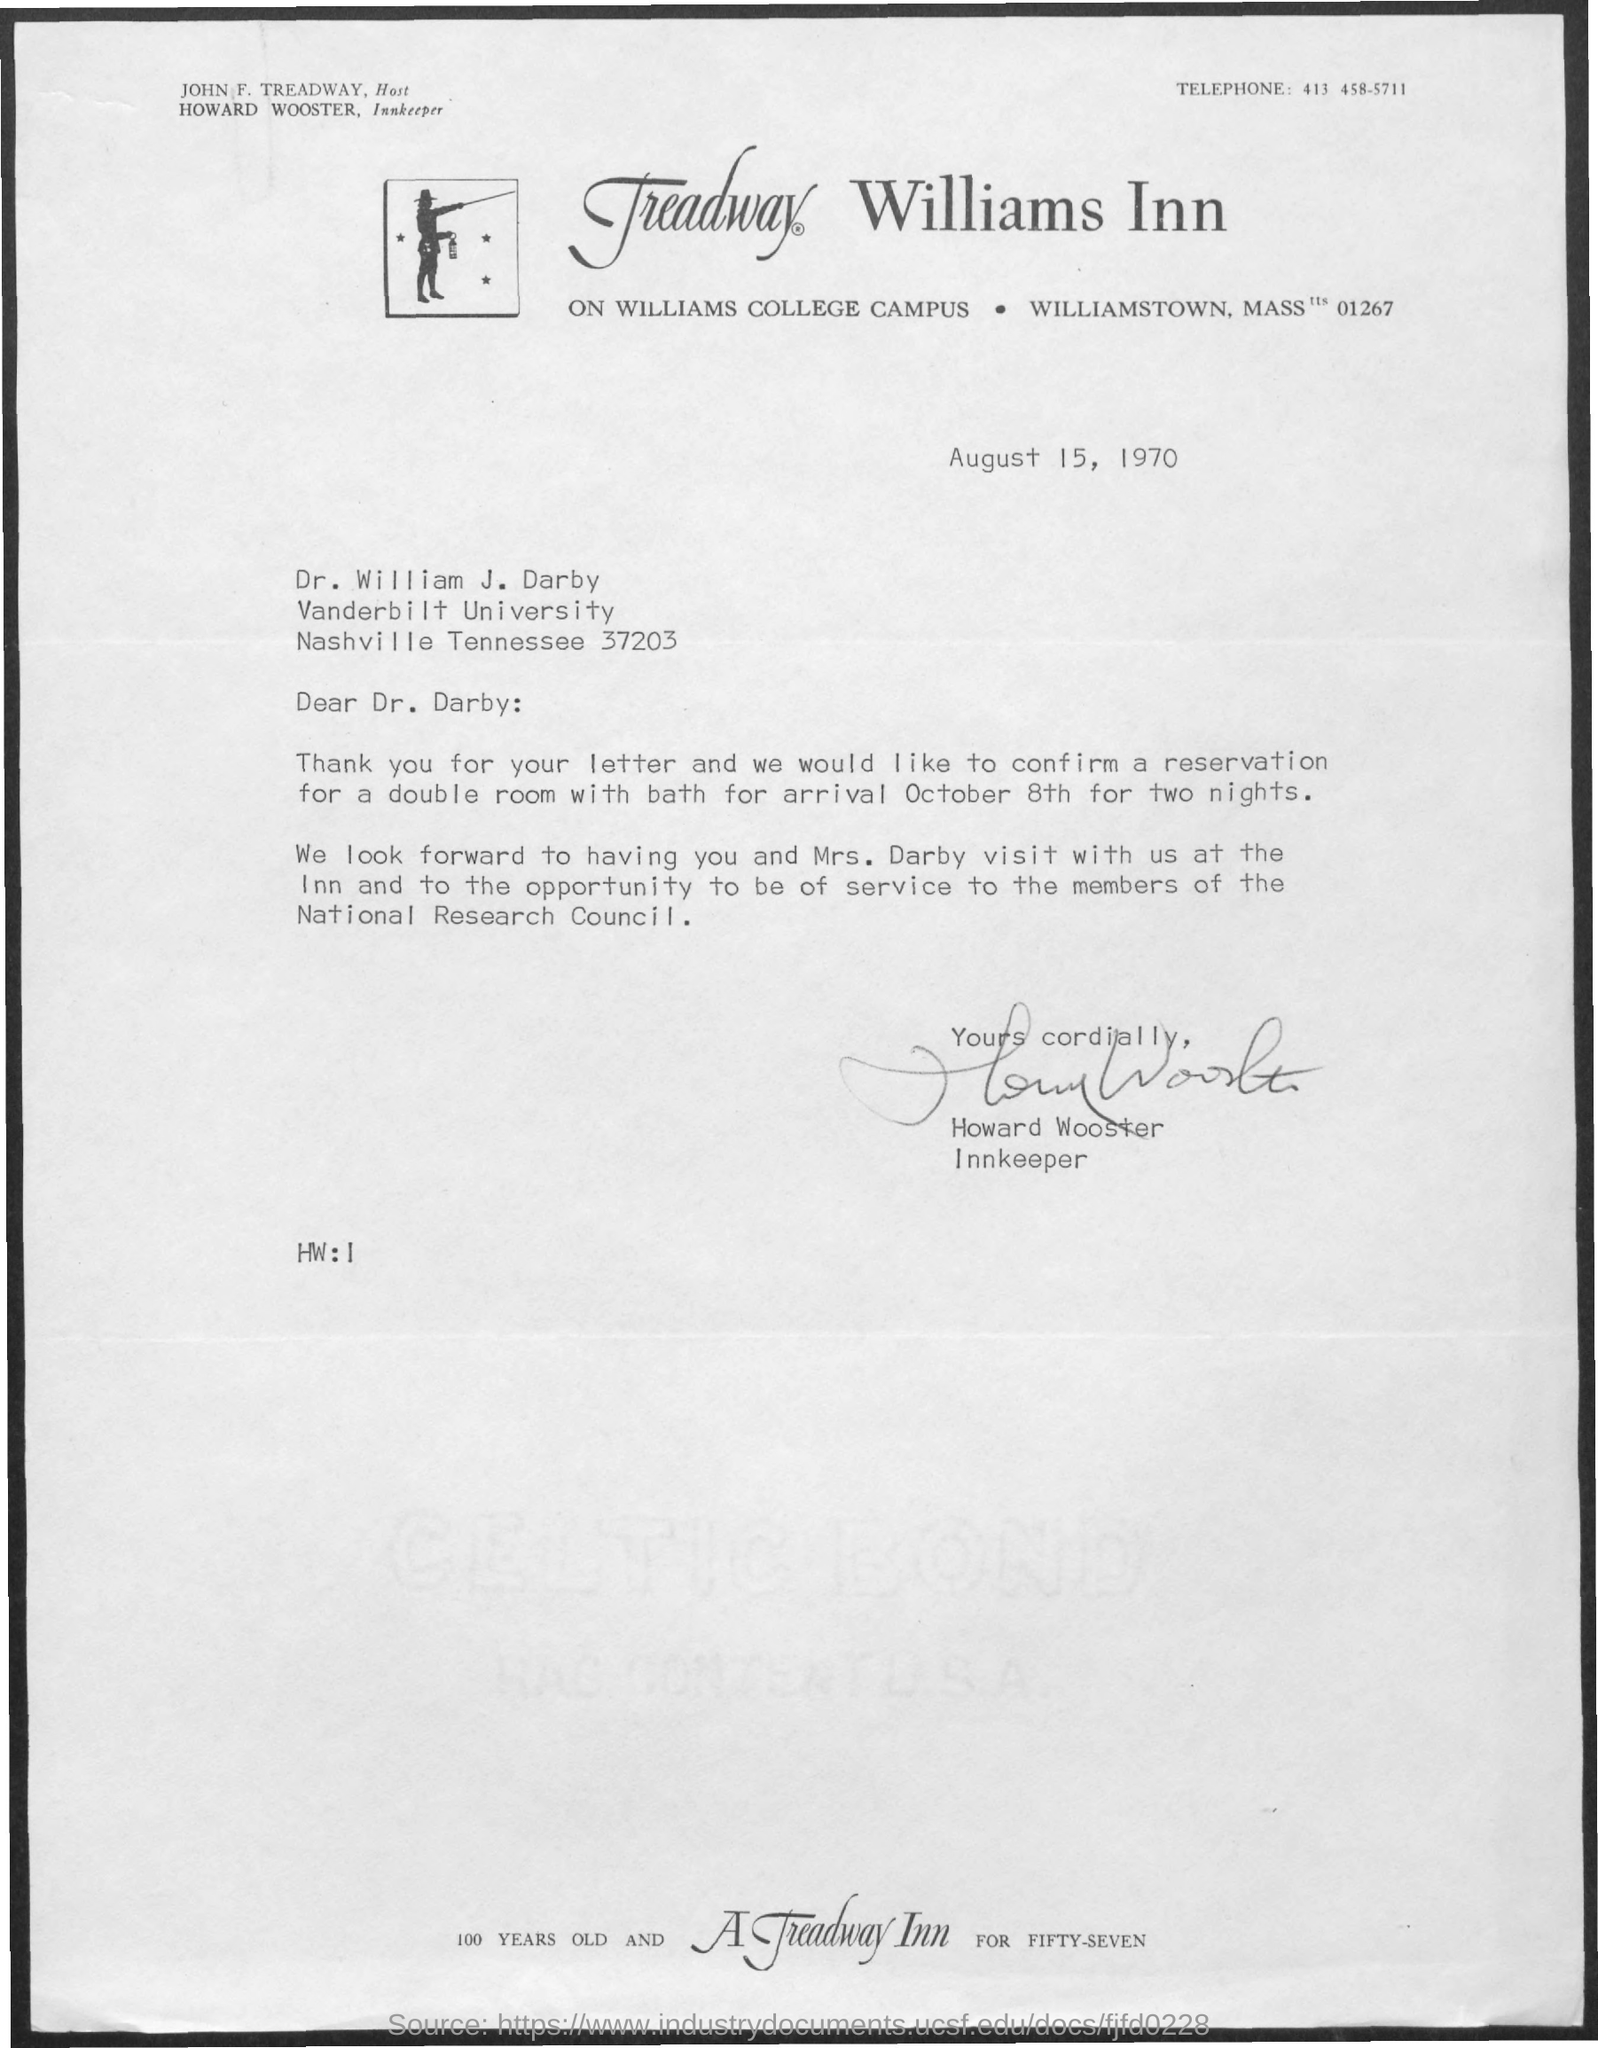What is the Telephone Number?
Keep it short and to the point. 413 458-5711. When is the memorandum dated on ?
Your answer should be very brief. August 15, 1970. Who is the memorandum from ?
Provide a short and direct response. Howard Wooster. 